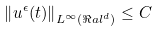<formula> <loc_0><loc_0><loc_500><loc_500>\left \| u ^ { \epsilon } ( t ) \right \| _ { L ^ { \infty } ( \Re a l ^ { d } ) } \leq C</formula> 